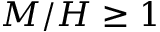Convert formula to latex. <formula><loc_0><loc_0><loc_500><loc_500>M / H \geq 1</formula> 